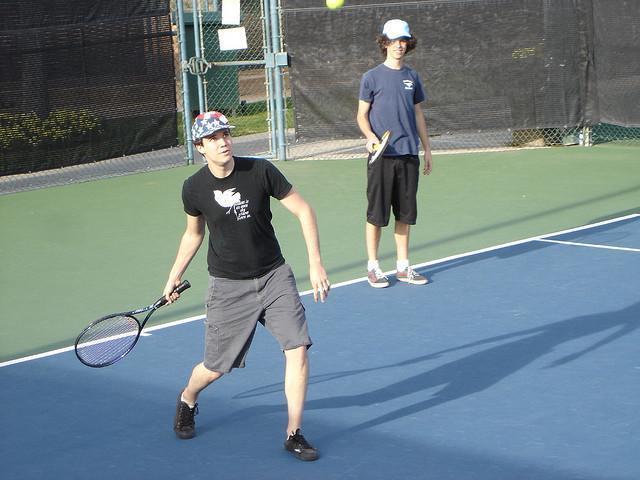How many young boys are there?
Give a very brief answer. 2. How many legs are there?
Give a very brief answer. 4. How many people are there?
Give a very brief answer. 2. 